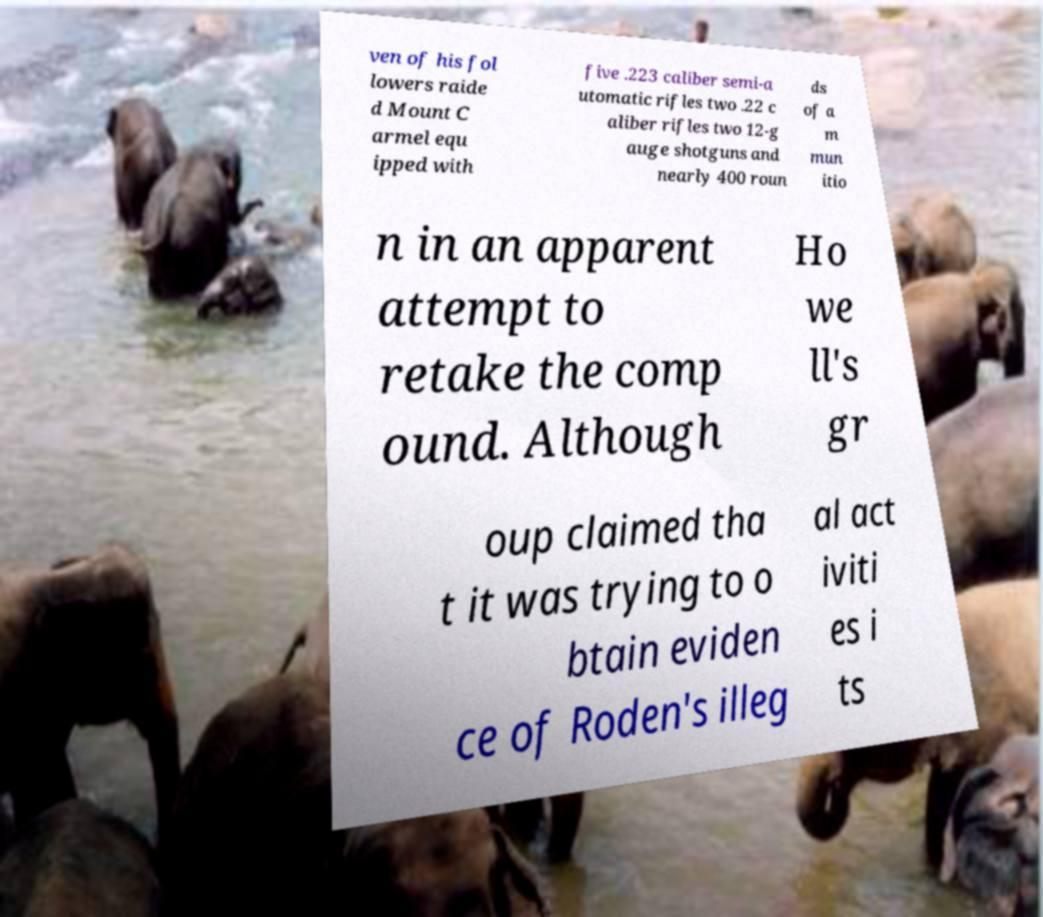For documentation purposes, I need the text within this image transcribed. Could you provide that? ven of his fol lowers raide d Mount C armel equ ipped with five .223 caliber semi-a utomatic rifles two .22 c aliber rifles two 12-g auge shotguns and nearly 400 roun ds of a m mun itio n in an apparent attempt to retake the comp ound. Although Ho we ll's gr oup claimed tha t it was trying to o btain eviden ce of Roden's illeg al act iviti es i ts 